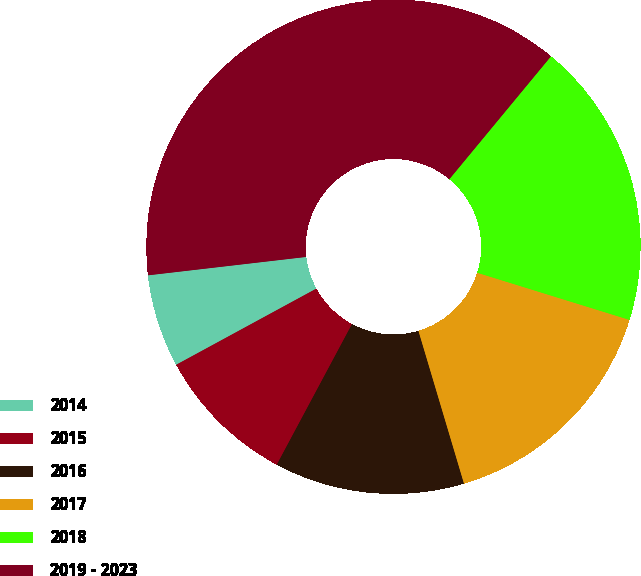Convert chart to OTSL. <chart><loc_0><loc_0><loc_500><loc_500><pie_chart><fcel>2014<fcel>2015<fcel>2016<fcel>2017<fcel>2018<fcel>2019 - 2023<nl><fcel>6.08%<fcel>9.26%<fcel>12.43%<fcel>15.61%<fcel>18.78%<fcel>37.84%<nl></chart> 